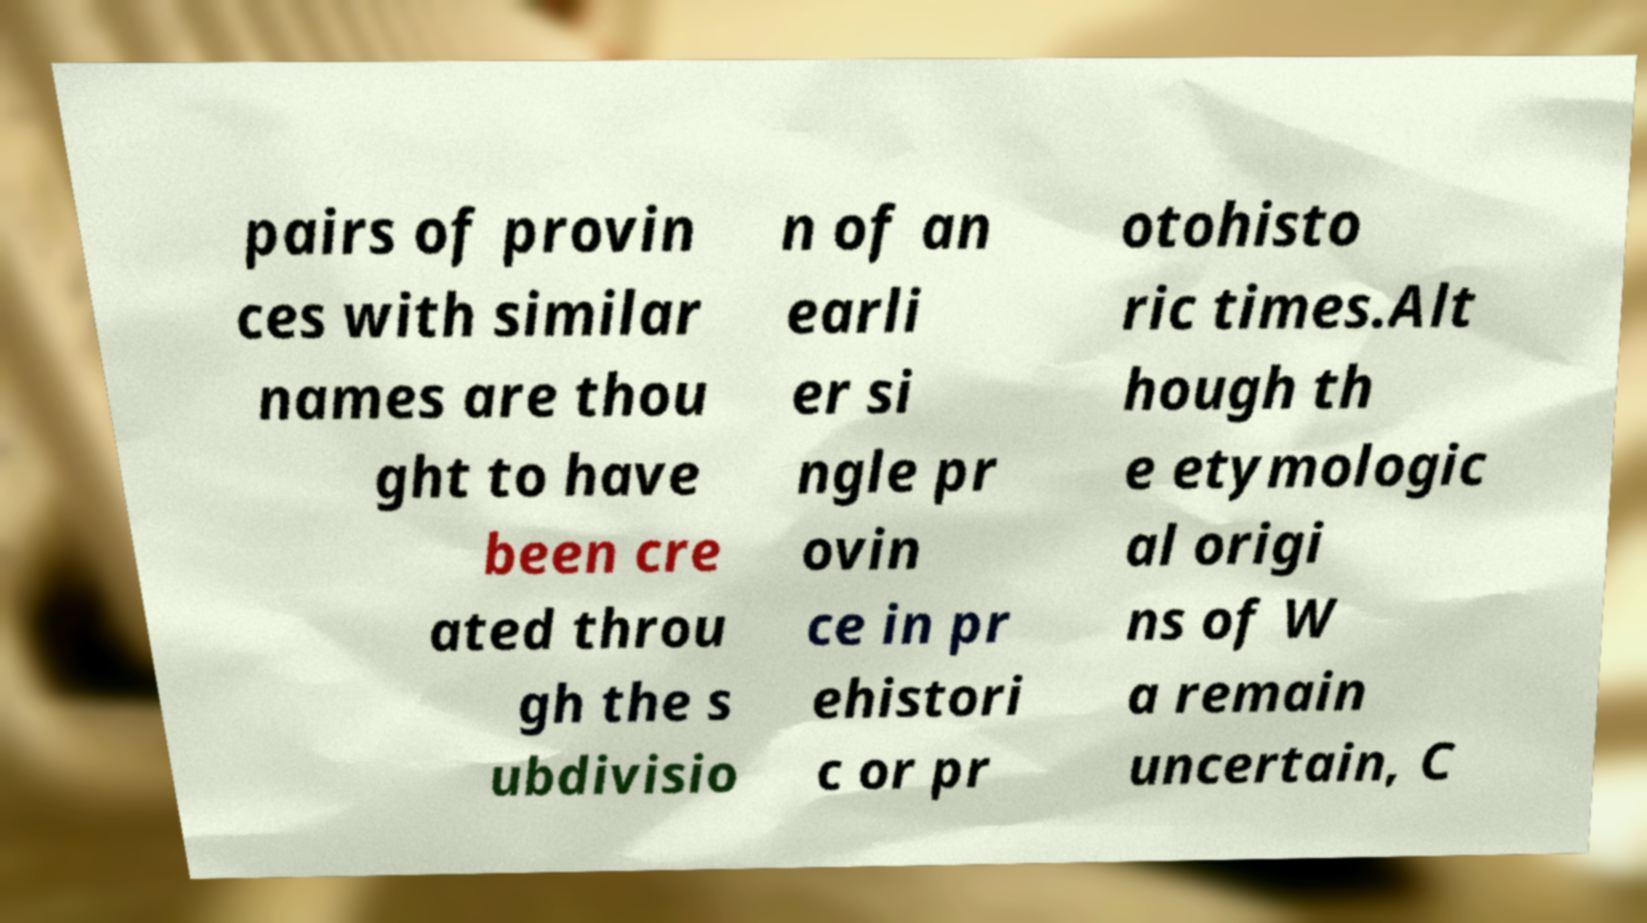For documentation purposes, I need the text within this image transcribed. Could you provide that? pairs of provin ces with similar names are thou ght to have been cre ated throu gh the s ubdivisio n of an earli er si ngle pr ovin ce in pr ehistori c or pr otohisto ric times.Alt hough th e etymologic al origi ns of W a remain uncertain, C 